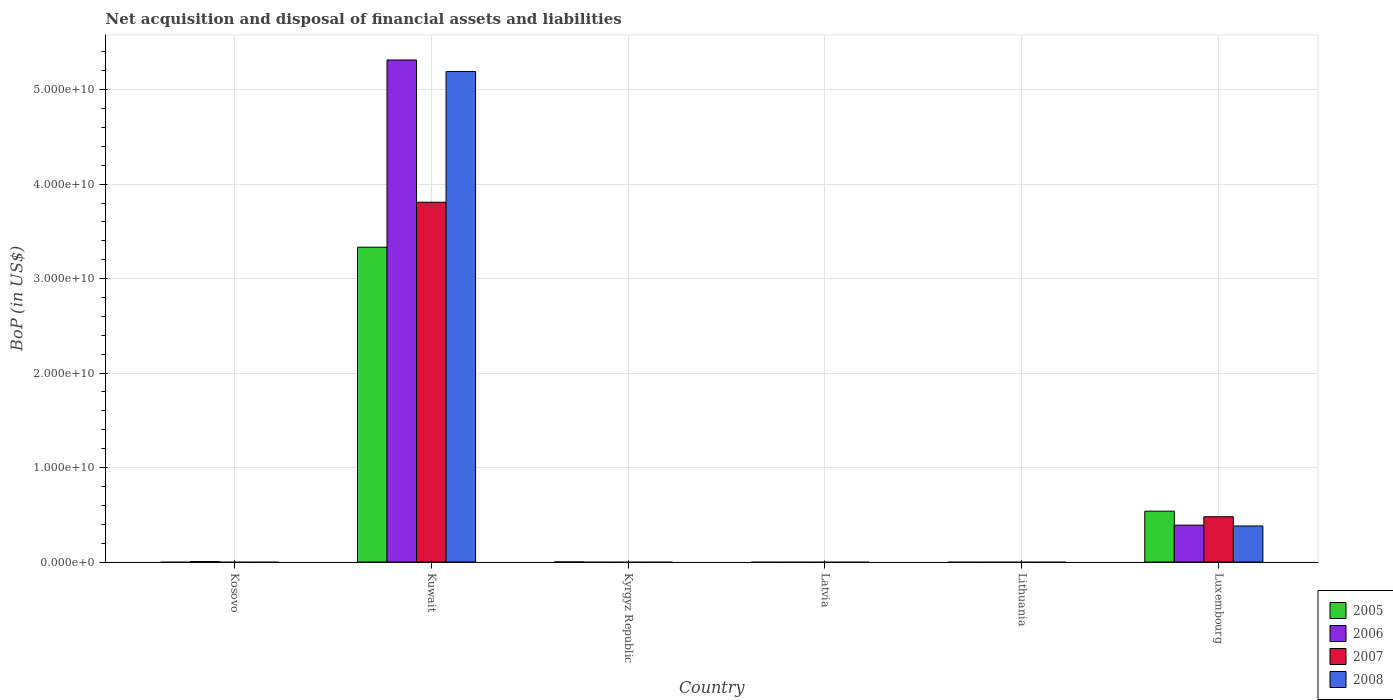Are the number of bars on each tick of the X-axis equal?
Provide a succinct answer. No. How many bars are there on the 1st tick from the left?
Offer a very short reply. 1. How many bars are there on the 3rd tick from the right?
Ensure brevity in your answer.  0. What is the label of the 1st group of bars from the left?
Provide a succinct answer. Kosovo. What is the Balance of Payments in 2007 in Lithuania?
Offer a very short reply. 0. Across all countries, what is the maximum Balance of Payments in 2008?
Provide a short and direct response. 5.19e+1. In which country was the Balance of Payments in 2008 maximum?
Your answer should be compact. Kuwait. What is the total Balance of Payments in 2006 in the graph?
Offer a terse response. 5.71e+1. What is the difference between the Balance of Payments in 2007 in Lithuania and the Balance of Payments in 2008 in Luxembourg?
Your answer should be very brief. -3.82e+09. What is the average Balance of Payments in 2008 per country?
Provide a short and direct response. 9.29e+09. What is the difference between the Balance of Payments of/in 2008 and Balance of Payments of/in 2005 in Luxembourg?
Your answer should be very brief. -1.57e+09. What is the difference between the highest and the second highest Balance of Payments in 2005?
Provide a succinct answer. -3.33e+1. What is the difference between the highest and the lowest Balance of Payments in 2007?
Provide a short and direct response. 3.81e+1. Is it the case that in every country, the sum of the Balance of Payments in 2008 and Balance of Payments in 2006 is greater than the sum of Balance of Payments in 2005 and Balance of Payments in 2007?
Your answer should be compact. No. Is it the case that in every country, the sum of the Balance of Payments in 2005 and Balance of Payments in 2006 is greater than the Balance of Payments in 2007?
Your response must be concise. No. How many bars are there?
Offer a very short reply. 10. How many countries are there in the graph?
Make the answer very short. 6. Are the values on the major ticks of Y-axis written in scientific E-notation?
Offer a very short reply. Yes. Where does the legend appear in the graph?
Give a very brief answer. Bottom right. How many legend labels are there?
Offer a very short reply. 4. What is the title of the graph?
Keep it short and to the point. Net acquisition and disposal of financial assets and liabilities. Does "2000" appear as one of the legend labels in the graph?
Give a very brief answer. No. What is the label or title of the Y-axis?
Offer a terse response. BoP (in US$). What is the BoP (in US$) of 2005 in Kosovo?
Offer a very short reply. 0. What is the BoP (in US$) of 2006 in Kosovo?
Your answer should be very brief. 4.48e+07. What is the BoP (in US$) in 2007 in Kosovo?
Your answer should be compact. 0. What is the BoP (in US$) in 2008 in Kosovo?
Keep it short and to the point. 0. What is the BoP (in US$) in 2005 in Kuwait?
Provide a short and direct response. 3.33e+1. What is the BoP (in US$) in 2006 in Kuwait?
Your answer should be very brief. 5.31e+1. What is the BoP (in US$) in 2007 in Kuwait?
Offer a very short reply. 3.81e+1. What is the BoP (in US$) of 2008 in Kuwait?
Provide a short and direct response. 5.19e+1. What is the BoP (in US$) of 2005 in Kyrgyz Republic?
Offer a very short reply. 7.59e+06. What is the BoP (in US$) of 2006 in Kyrgyz Republic?
Offer a very short reply. 0. What is the BoP (in US$) in 2007 in Kyrgyz Republic?
Your answer should be compact. 0. What is the BoP (in US$) of 2006 in Latvia?
Offer a very short reply. 0. What is the BoP (in US$) of 2008 in Latvia?
Your response must be concise. 0. What is the BoP (in US$) in 2005 in Lithuania?
Keep it short and to the point. 0. What is the BoP (in US$) of 2006 in Lithuania?
Your answer should be very brief. 0. What is the BoP (in US$) of 2007 in Lithuania?
Provide a succinct answer. 0. What is the BoP (in US$) of 2008 in Lithuania?
Provide a succinct answer. 0. What is the BoP (in US$) of 2005 in Luxembourg?
Your response must be concise. 5.38e+09. What is the BoP (in US$) in 2006 in Luxembourg?
Your answer should be compact. 3.90e+09. What is the BoP (in US$) of 2007 in Luxembourg?
Ensure brevity in your answer.  4.79e+09. What is the BoP (in US$) of 2008 in Luxembourg?
Offer a very short reply. 3.82e+09. Across all countries, what is the maximum BoP (in US$) in 2005?
Give a very brief answer. 3.33e+1. Across all countries, what is the maximum BoP (in US$) of 2006?
Offer a very short reply. 5.31e+1. Across all countries, what is the maximum BoP (in US$) in 2007?
Make the answer very short. 3.81e+1. Across all countries, what is the maximum BoP (in US$) in 2008?
Provide a succinct answer. 5.19e+1. Across all countries, what is the minimum BoP (in US$) of 2008?
Make the answer very short. 0. What is the total BoP (in US$) of 2005 in the graph?
Provide a short and direct response. 3.87e+1. What is the total BoP (in US$) in 2006 in the graph?
Offer a very short reply. 5.71e+1. What is the total BoP (in US$) in 2007 in the graph?
Offer a very short reply. 4.29e+1. What is the total BoP (in US$) in 2008 in the graph?
Offer a terse response. 5.57e+1. What is the difference between the BoP (in US$) of 2006 in Kosovo and that in Kuwait?
Provide a short and direct response. -5.31e+1. What is the difference between the BoP (in US$) in 2006 in Kosovo and that in Luxembourg?
Ensure brevity in your answer.  -3.86e+09. What is the difference between the BoP (in US$) of 2005 in Kuwait and that in Kyrgyz Republic?
Keep it short and to the point. 3.33e+1. What is the difference between the BoP (in US$) of 2005 in Kuwait and that in Luxembourg?
Your answer should be very brief. 2.79e+1. What is the difference between the BoP (in US$) in 2006 in Kuwait and that in Luxembourg?
Give a very brief answer. 4.92e+1. What is the difference between the BoP (in US$) in 2007 in Kuwait and that in Luxembourg?
Make the answer very short. 3.33e+1. What is the difference between the BoP (in US$) in 2008 in Kuwait and that in Luxembourg?
Provide a short and direct response. 4.81e+1. What is the difference between the BoP (in US$) of 2005 in Kyrgyz Republic and that in Luxembourg?
Ensure brevity in your answer.  -5.38e+09. What is the difference between the BoP (in US$) in 2006 in Kosovo and the BoP (in US$) in 2007 in Kuwait?
Offer a terse response. -3.80e+1. What is the difference between the BoP (in US$) of 2006 in Kosovo and the BoP (in US$) of 2008 in Kuwait?
Offer a terse response. -5.19e+1. What is the difference between the BoP (in US$) of 2006 in Kosovo and the BoP (in US$) of 2007 in Luxembourg?
Your response must be concise. -4.75e+09. What is the difference between the BoP (in US$) in 2006 in Kosovo and the BoP (in US$) in 2008 in Luxembourg?
Keep it short and to the point. -3.77e+09. What is the difference between the BoP (in US$) in 2005 in Kuwait and the BoP (in US$) in 2006 in Luxembourg?
Your response must be concise. 2.94e+1. What is the difference between the BoP (in US$) of 2005 in Kuwait and the BoP (in US$) of 2007 in Luxembourg?
Make the answer very short. 2.85e+1. What is the difference between the BoP (in US$) of 2005 in Kuwait and the BoP (in US$) of 2008 in Luxembourg?
Provide a succinct answer. 2.95e+1. What is the difference between the BoP (in US$) in 2006 in Kuwait and the BoP (in US$) in 2007 in Luxembourg?
Your answer should be compact. 4.83e+1. What is the difference between the BoP (in US$) of 2006 in Kuwait and the BoP (in US$) of 2008 in Luxembourg?
Your answer should be very brief. 4.93e+1. What is the difference between the BoP (in US$) of 2007 in Kuwait and the BoP (in US$) of 2008 in Luxembourg?
Ensure brevity in your answer.  3.43e+1. What is the difference between the BoP (in US$) in 2005 in Kyrgyz Republic and the BoP (in US$) in 2006 in Luxembourg?
Offer a very short reply. -3.90e+09. What is the difference between the BoP (in US$) in 2005 in Kyrgyz Republic and the BoP (in US$) in 2007 in Luxembourg?
Your answer should be compact. -4.79e+09. What is the difference between the BoP (in US$) of 2005 in Kyrgyz Republic and the BoP (in US$) of 2008 in Luxembourg?
Your response must be concise. -3.81e+09. What is the average BoP (in US$) of 2005 per country?
Your answer should be very brief. 6.45e+09. What is the average BoP (in US$) in 2006 per country?
Your answer should be compact. 9.52e+09. What is the average BoP (in US$) of 2007 per country?
Your answer should be very brief. 7.15e+09. What is the average BoP (in US$) in 2008 per country?
Offer a terse response. 9.29e+09. What is the difference between the BoP (in US$) in 2005 and BoP (in US$) in 2006 in Kuwait?
Make the answer very short. -1.98e+1. What is the difference between the BoP (in US$) in 2005 and BoP (in US$) in 2007 in Kuwait?
Provide a succinct answer. -4.76e+09. What is the difference between the BoP (in US$) in 2005 and BoP (in US$) in 2008 in Kuwait?
Offer a terse response. -1.86e+1. What is the difference between the BoP (in US$) of 2006 and BoP (in US$) of 2007 in Kuwait?
Your answer should be compact. 1.51e+1. What is the difference between the BoP (in US$) of 2006 and BoP (in US$) of 2008 in Kuwait?
Keep it short and to the point. 1.22e+09. What is the difference between the BoP (in US$) of 2007 and BoP (in US$) of 2008 in Kuwait?
Your answer should be very brief. -1.38e+1. What is the difference between the BoP (in US$) in 2005 and BoP (in US$) in 2006 in Luxembourg?
Your response must be concise. 1.48e+09. What is the difference between the BoP (in US$) in 2005 and BoP (in US$) in 2007 in Luxembourg?
Provide a short and direct response. 5.90e+08. What is the difference between the BoP (in US$) of 2005 and BoP (in US$) of 2008 in Luxembourg?
Your answer should be very brief. 1.57e+09. What is the difference between the BoP (in US$) of 2006 and BoP (in US$) of 2007 in Luxembourg?
Your answer should be very brief. -8.89e+08. What is the difference between the BoP (in US$) of 2006 and BoP (in US$) of 2008 in Luxembourg?
Provide a short and direct response. 8.81e+07. What is the difference between the BoP (in US$) in 2007 and BoP (in US$) in 2008 in Luxembourg?
Keep it short and to the point. 9.77e+08. What is the ratio of the BoP (in US$) of 2006 in Kosovo to that in Kuwait?
Provide a short and direct response. 0. What is the ratio of the BoP (in US$) of 2006 in Kosovo to that in Luxembourg?
Keep it short and to the point. 0.01. What is the ratio of the BoP (in US$) in 2005 in Kuwait to that in Kyrgyz Republic?
Make the answer very short. 4390.01. What is the ratio of the BoP (in US$) of 2005 in Kuwait to that in Luxembourg?
Offer a very short reply. 6.19. What is the ratio of the BoP (in US$) in 2006 in Kuwait to that in Luxembourg?
Give a very brief answer. 13.61. What is the ratio of the BoP (in US$) of 2007 in Kuwait to that in Luxembourg?
Keep it short and to the point. 7.95. What is the ratio of the BoP (in US$) in 2008 in Kuwait to that in Luxembourg?
Your answer should be compact. 13.6. What is the ratio of the BoP (in US$) in 2005 in Kyrgyz Republic to that in Luxembourg?
Your answer should be very brief. 0. What is the difference between the highest and the second highest BoP (in US$) in 2005?
Provide a short and direct response. 2.79e+1. What is the difference between the highest and the second highest BoP (in US$) in 2006?
Your answer should be compact. 4.92e+1. What is the difference between the highest and the lowest BoP (in US$) in 2005?
Keep it short and to the point. 3.33e+1. What is the difference between the highest and the lowest BoP (in US$) of 2006?
Give a very brief answer. 5.31e+1. What is the difference between the highest and the lowest BoP (in US$) in 2007?
Keep it short and to the point. 3.81e+1. What is the difference between the highest and the lowest BoP (in US$) of 2008?
Provide a succinct answer. 5.19e+1. 